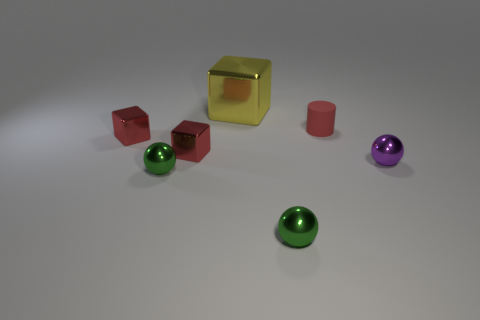Subtract all brown cylinders. How many green spheres are left? 2 Add 1 small purple things. How many objects exist? 8 Subtract all big yellow blocks. How many blocks are left? 2 Subtract 1 blocks. How many blocks are left? 2 Subtract all cylinders. How many objects are left? 6 Add 1 small purple things. How many small purple things exist? 2 Subtract 0 red balls. How many objects are left? 7 Subtract all tiny purple rubber cubes. Subtract all rubber cylinders. How many objects are left? 6 Add 1 purple shiny spheres. How many purple shiny spheres are left? 2 